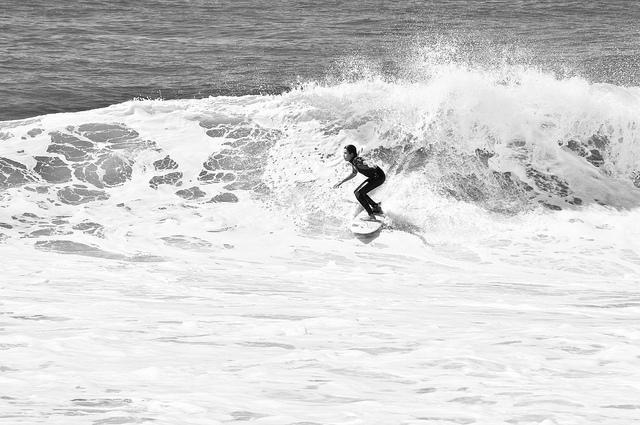How many white toilets with brown lids are in this image?
Give a very brief answer. 0. 